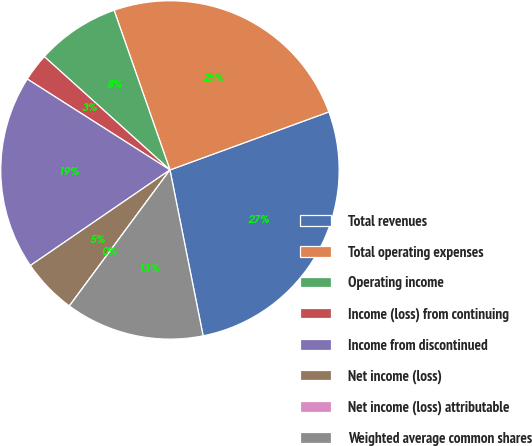<chart> <loc_0><loc_0><loc_500><loc_500><pie_chart><fcel>Total revenues<fcel>Total operating expenses<fcel>Operating income<fcel>Income (loss) from continuing<fcel>Income from discontinued<fcel>Net income (loss)<fcel>Net income (loss) attributable<fcel>Weighted average common shares<nl><fcel>27.43%<fcel>24.78%<fcel>7.96%<fcel>2.65%<fcel>18.58%<fcel>5.31%<fcel>0.0%<fcel>13.27%<nl></chart> 